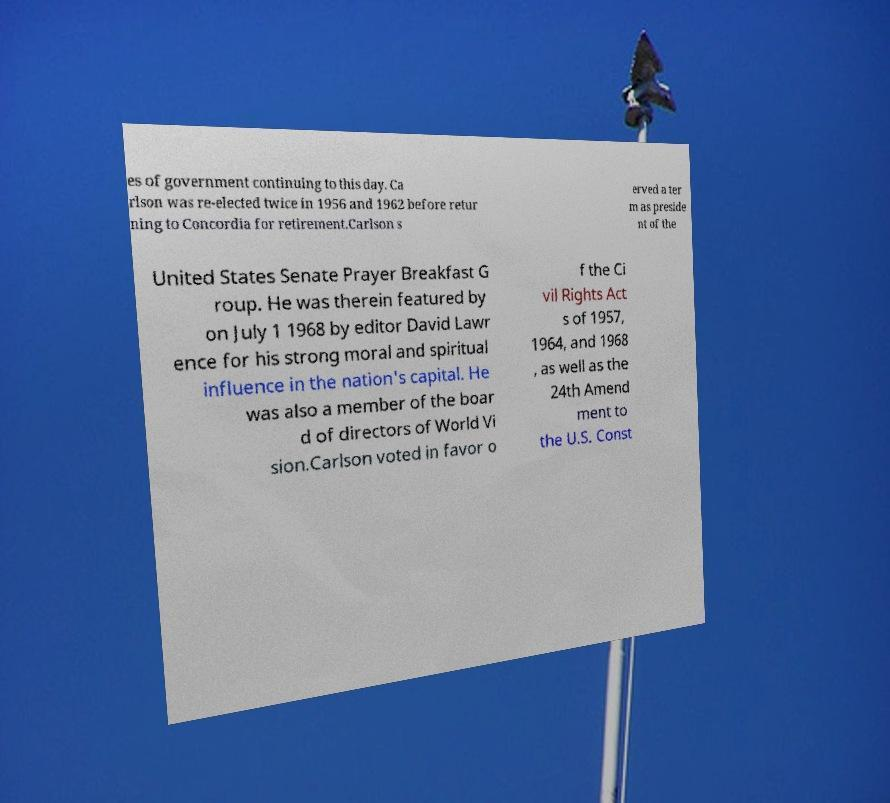There's text embedded in this image that I need extracted. Can you transcribe it verbatim? es of government continuing to this day. Ca rlson was re-elected twice in 1956 and 1962 before retur ning to Concordia for retirement.Carlson s erved a ter m as preside nt of the United States Senate Prayer Breakfast G roup. He was therein featured by on July 1 1968 by editor David Lawr ence for his strong moral and spiritual influence in the nation's capital. He was also a member of the boar d of directors of World Vi sion.Carlson voted in favor o f the Ci vil Rights Act s of 1957, 1964, and 1968 , as well as the 24th Amend ment to the U.S. Const 